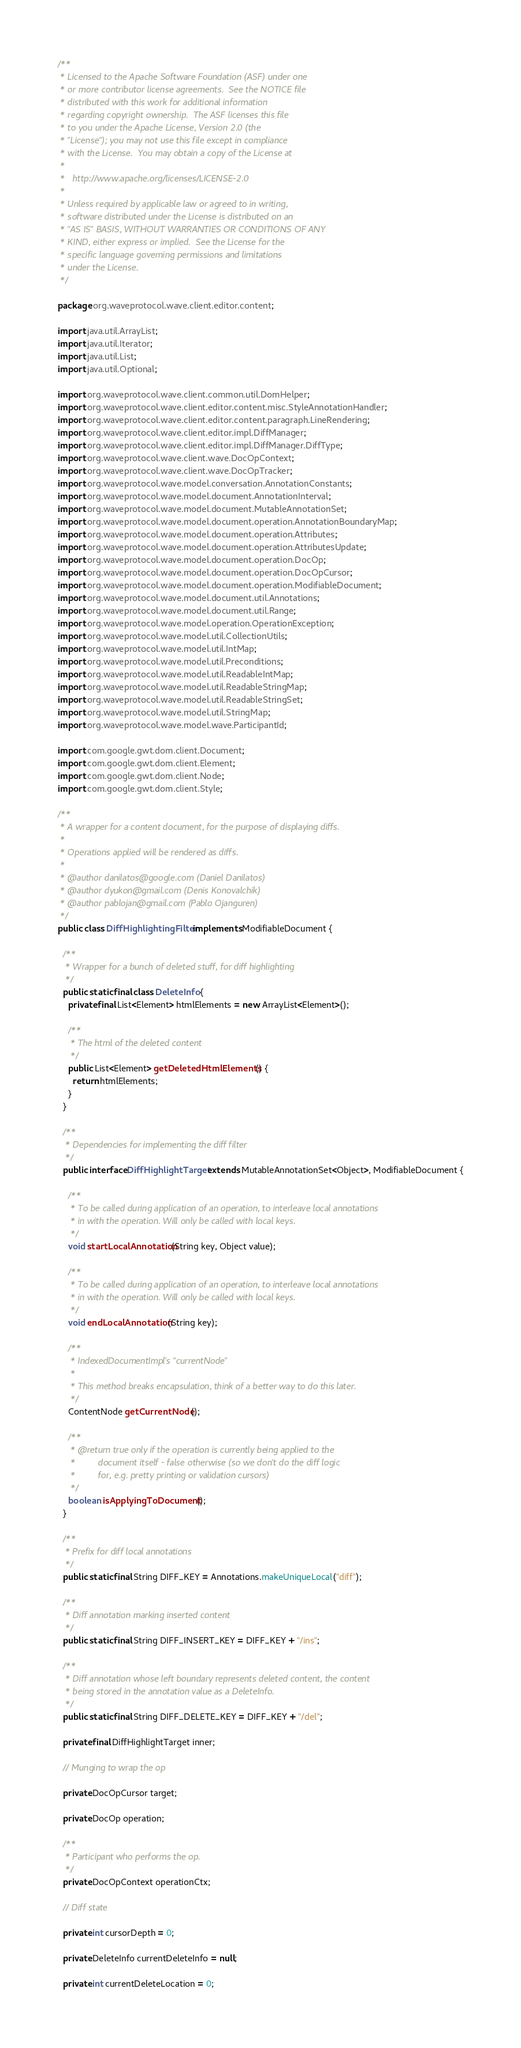Convert code to text. <code><loc_0><loc_0><loc_500><loc_500><_Java_>/**
 * Licensed to the Apache Software Foundation (ASF) under one
 * or more contributor license agreements.  See the NOTICE file
 * distributed with this work for additional information
 * regarding copyright ownership.  The ASF licenses this file
 * to you under the Apache License, Version 2.0 (the
 * "License"); you may not use this file except in compliance
 * with the License.  You may obtain a copy of the License at
 *
 *   http://www.apache.org/licenses/LICENSE-2.0
 *
 * Unless required by applicable law or agreed to in writing,
 * software distributed under the License is distributed on an
 * "AS IS" BASIS, WITHOUT WARRANTIES OR CONDITIONS OF ANY
 * KIND, either express or implied.  See the License for the
 * specific language governing permissions and limitations
 * under the License.
 */

package org.waveprotocol.wave.client.editor.content;

import java.util.ArrayList;
import java.util.Iterator;
import java.util.List;
import java.util.Optional;

import org.waveprotocol.wave.client.common.util.DomHelper;
import org.waveprotocol.wave.client.editor.content.misc.StyleAnnotationHandler;
import org.waveprotocol.wave.client.editor.content.paragraph.LineRendering;
import org.waveprotocol.wave.client.editor.impl.DiffManager;
import org.waveprotocol.wave.client.editor.impl.DiffManager.DiffType;
import org.waveprotocol.wave.client.wave.DocOpContext;
import org.waveprotocol.wave.client.wave.DocOpTracker;
import org.waveprotocol.wave.model.conversation.AnnotationConstants;
import org.waveprotocol.wave.model.document.AnnotationInterval;
import org.waveprotocol.wave.model.document.MutableAnnotationSet;
import org.waveprotocol.wave.model.document.operation.AnnotationBoundaryMap;
import org.waveprotocol.wave.model.document.operation.Attributes;
import org.waveprotocol.wave.model.document.operation.AttributesUpdate;
import org.waveprotocol.wave.model.document.operation.DocOp;
import org.waveprotocol.wave.model.document.operation.DocOpCursor;
import org.waveprotocol.wave.model.document.operation.ModifiableDocument;
import org.waveprotocol.wave.model.document.util.Annotations;
import org.waveprotocol.wave.model.document.util.Range;
import org.waveprotocol.wave.model.operation.OperationException;
import org.waveprotocol.wave.model.util.CollectionUtils;
import org.waveprotocol.wave.model.util.IntMap;
import org.waveprotocol.wave.model.util.Preconditions;
import org.waveprotocol.wave.model.util.ReadableIntMap;
import org.waveprotocol.wave.model.util.ReadableStringMap;
import org.waveprotocol.wave.model.util.ReadableStringSet;
import org.waveprotocol.wave.model.util.StringMap;
import org.waveprotocol.wave.model.wave.ParticipantId;

import com.google.gwt.dom.client.Document;
import com.google.gwt.dom.client.Element;
import com.google.gwt.dom.client.Node;
import com.google.gwt.dom.client.Style;

/**
 * A wrapper for a content document, for the purpose of displaying diffs.
 *
 * Operations applied will be rendered as diffs.
 *
 * @author danilatos@google.com (Daniel Danilatos)
 * @author dyukon@gmail.com (Denis Konovalchik)
 * @author pablojan@gmail.com (Pablo Ojanguren)
 */
public class DiffHighlightingFilter implements ModifiableDocument {

  /**
   * Wrapper for a bunch of deleted stuff, for diff highlighting
   */
  public static final class DeleteInfo {
    private final List<Element> htmlElements = new ArrayList<Element>();

    /**
     * The html of the deleted content
     */
    public List<Element> getDeletedHtmlElements() {
      return htmlElements;
    }
  }

  /**
   * Dependencies for implementing the diff filter
   */
  public interface DiffHighlightTarget extends MutableAnnotationSet<Object>, ModifiableDocument {

    /**
     * To be called during application of an operation, to interleave local annotations
     * in with the operation. Will only be called with local keys.
     */
    void startLocalAnnotation(String key, Object value);

    /**
     * To be called during application of an operation, to interleave local annotations
     * in with the operation. Will only be called with local keys.
     */
    void endLocalAnnotation(String key);

    /**
     * IndexedDocumentImpl's "currentNode"
     *
     * This method breaks encapsulation, think of a better way to do this later.
     */
    ContentNode getCurrentNode();

    /**
     * @return true only if the operation is currently being applied to the
     *         document itself - false otherwise (so we don't do the diff logic
     *         for, e.g. pretty printing or validation cursors)
     */
    boolean isApplyingToDocument();
  }

  /**
   * Prefix for diff local annotations
   */
  public static final String DIFF_KEY = Annotations.makeUniqueLocal("diff");

  /**
   * Diff annotation marking inserted content
   */
  public static final String DIFF_INSERT_KEY = DIFF_KEY + "/ins";

  /**
   * Diff annotation whose left boundary represents deleted content, the content
   * being stored in the annotation value as a DeleteInfo.
   */
  public static final String DIFF_DELETE_KEY = DIFF_KEY + "/del";

  private final DiffHighlightTarget inner;

  // Munging to wrap the op

  private DocOpCursor target;

  private DocOp operation;

  /**
   * Participant who performs the op.
   */
  private DocOpContext operationCtx;

  // Diff state

  private int cursorDepth = 0;

  private DeleteInfo currentDeleteInfo = null;

  private int currentDeleteLocation = 0;
</code> 